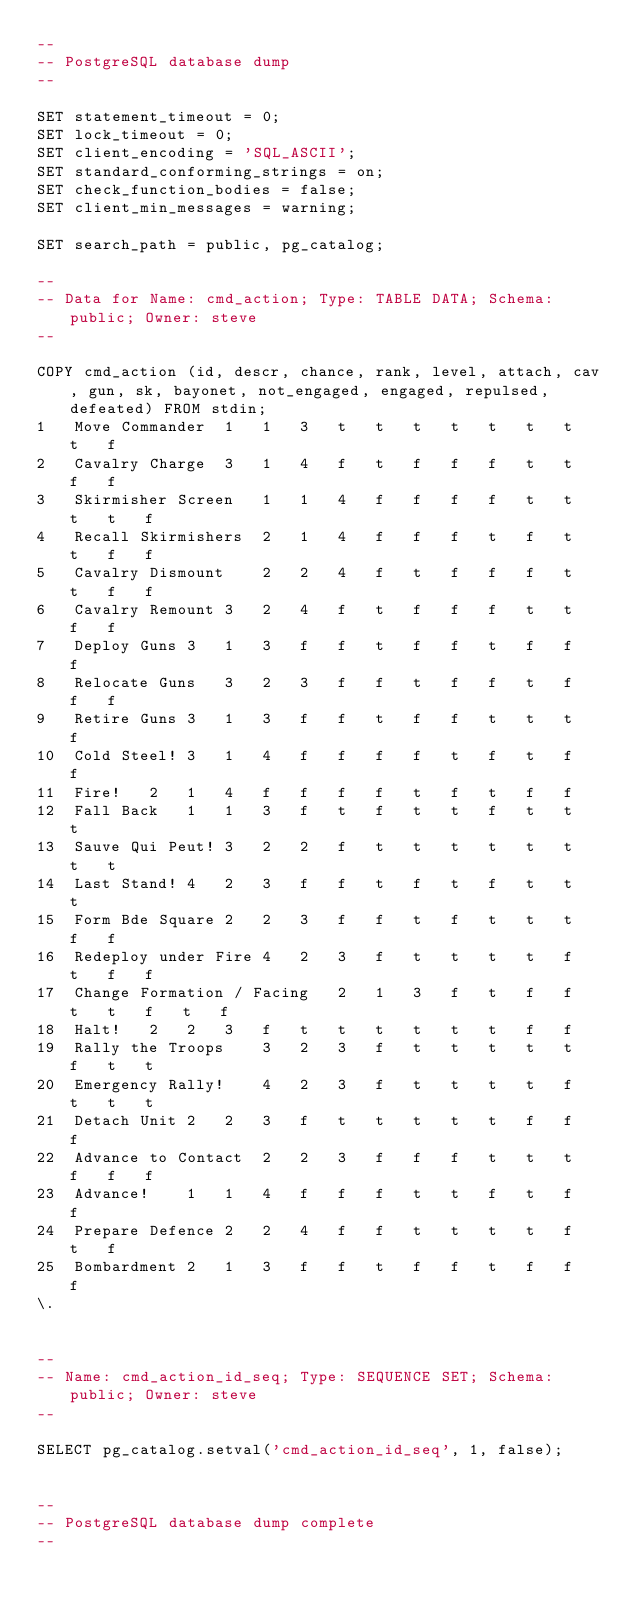Convert code to text. <code><loc_0><loc_0><loc_500><loc_500><_SQL_>--
-- PostgreSQL database dump
--

SET statement_timeout = 0;
SET lock_timeout = 0;
SET client_encoding = 'SQL_ASCII';
SET standard_conforming_strings = on;
SET check_function_bodies = false;
SET client_min_messages = warning;

SET search_path = public, pg_catalog;

--
-- Data for Name: cmd_action; Type: TABLE DATA; Schema: public; Owner: steve
--

COPY cmd_action (id, descr, chance, rank, level, attach, cav, gun, sk, bayonet, not_engaged, engaged, repulsed, defeated) FROM stdin;
1	Move Commander	1	1	3	t	t	t	t	t	t	t	t	f
2	Cavalry Charge	3	1	4	f	t	f	f	f	t	t	f	f
3	Skirmisher Screen	1	1	4	f	f	f	f	t	t	t	t	f
4	Recall Skirmishers	2	1	4	f	f	f	t	f	t	t	f	f
5	Cavalry Dismount	2	2	4	f	t	f	f	f	t	t	f	f
6	Cavalry Remount	3	2	4	f	t	f	f	f	t	t	f	f
7	Deploy Guns	3	1	3	f	f	t	f	f	t	f	f	f
8	Relocate Guns	3	2	3	f	f	t	f	f	t	f	f	f
9	Retire Guns	3	1	3	f	f	t	f	f	t	t	t	f
10	Cold Steel!	3	1	4	f	f	f	f	t	f	t	f	f
11	Fire!	2	1	4	f	f	f	f	t	f	t	f	f
12	Fall Back	1	1	3	f	t	f	t	t	f	t	t	t
13	Sauve Qui Peut!	3	2	2	f	t	t	t	t	t	t	t	t
14	Last Stand!	4	2	3	f	f	t	f	t	f	t	t	t
15	Form Bde Square	2	2	3	f	f	t	f	t	t	t	f	f
16	Redeploy under Fire	4	2	3	f	t	t	t	t	f	t	f	f
17	Change Formation / Facing	2	1	3	f	t	f	f	t	t	f	t	f
18	Halt!	2	2	3	f	t	t	t	t	t	t	f	f
19	Rally the Troops	3	2	3	f	t	t	t	t	t	f	t	t
20	Emergency Rally!	4	2	3	f	t	t	t	t	f	t	t	t
21	Detach Unit	2	2	3	f	t	t	t	t	t	f	f	f
22	Advance to Contact	2	2	3	f	f	f	t	t	t	f	f	f
23	Advance!	1	1	4	f	f	f	t	t	f	t	f	f
24	Prepare Defence	2	2	4	f	f	t	t	t	t	f	t	f
25	Bombardment	2	1	3	f	f	t	f	f	t	f	f	f
\.


--
-- Name: cmd_action_id_seq; Type: SEQUENCE SET; Schema: public; Owner: steve
--

SELECT pg_catalog.setval('cmd_action_id_seq', 1, false);


--
-- PostgreSQL database dump complete
--

</code> 